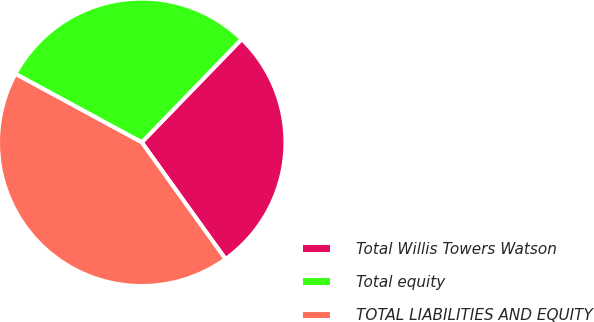<chart> <loc_0><loc_0><loc_500><loc_500><pie_chart><fcel>Total Willis Towers Watson<fcel>Total equity<fcel>TOTAL LIABILITIES AND EQUITY<nl><fcel>27.85%<fcel>29.34%<fcel>42.81%<nl></chart> 